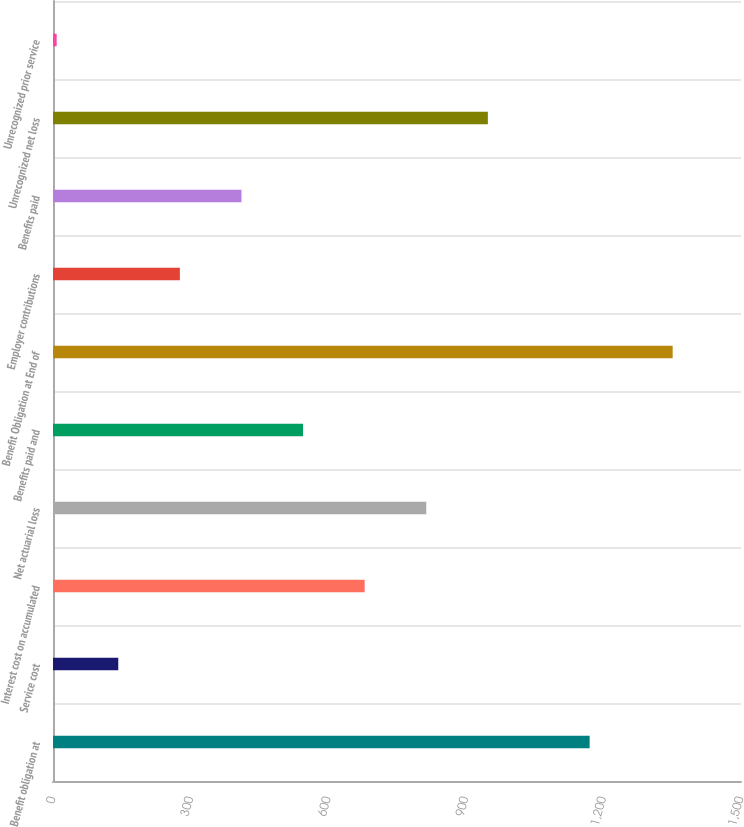<chart> <loc_0><loc_0><loc_500><loc_500><bar_chart><fcel>Benefit obligation at<fcel>Service cost<fcel>Interest cost on accumulated<fcel>Net actuarial loss<fcel>Benefits paid and<fcel>Benefit Obligation at End of<fcel>Employer contributions<fcel>Benefits paid<fcel>Unrecognized net loss<fcel>Unrecognized prior service<nl><fcel>1170<fcel>142.3<fcel>679.5<fcel>813.8<fcel>545.2<fcel>1351<fcel>276.6<fcel>410.9<fcel>948.1<fcel>8<nl></chart> 